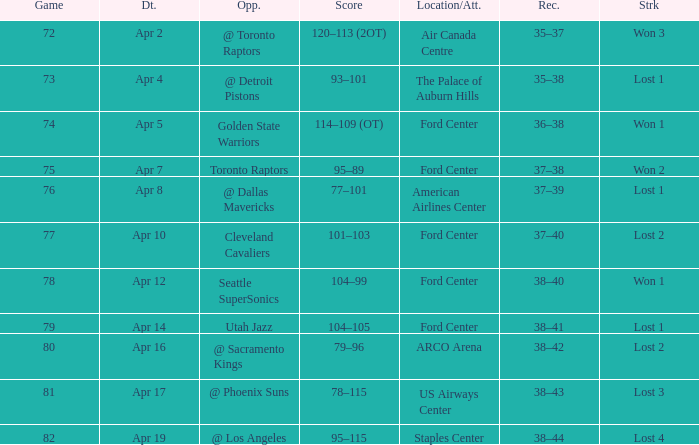What was the location when the opponent was Seattle Supersonics? Ford Center. 